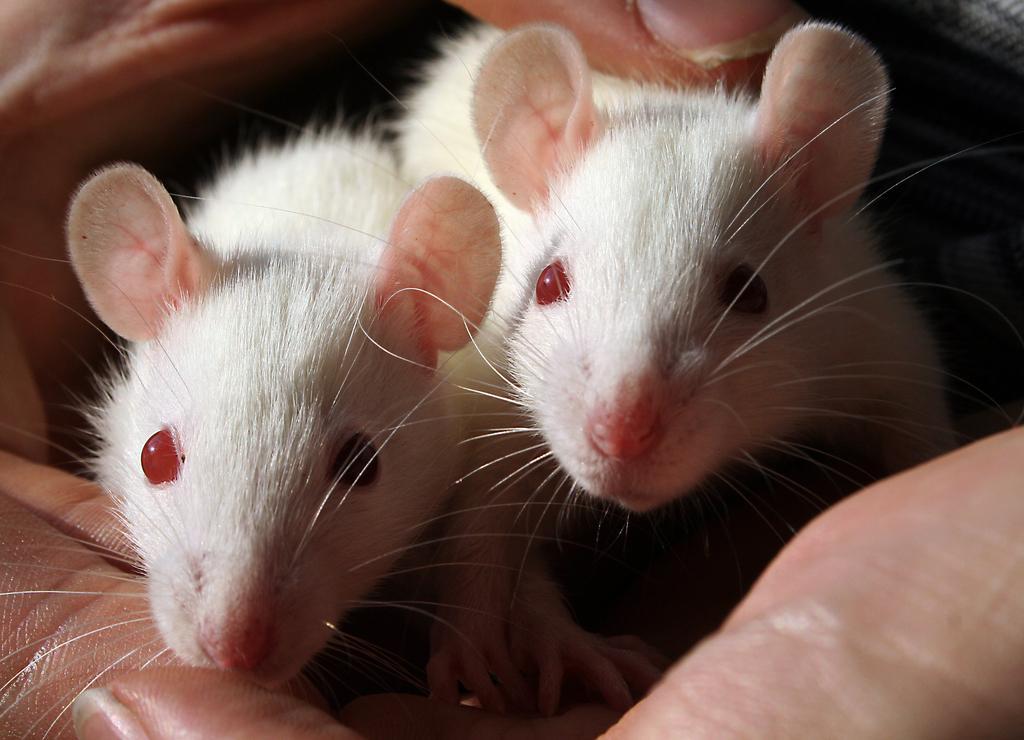Please provide a concise description of this image. In the middle of this image, there are two white color mouses in the hands of a person. 